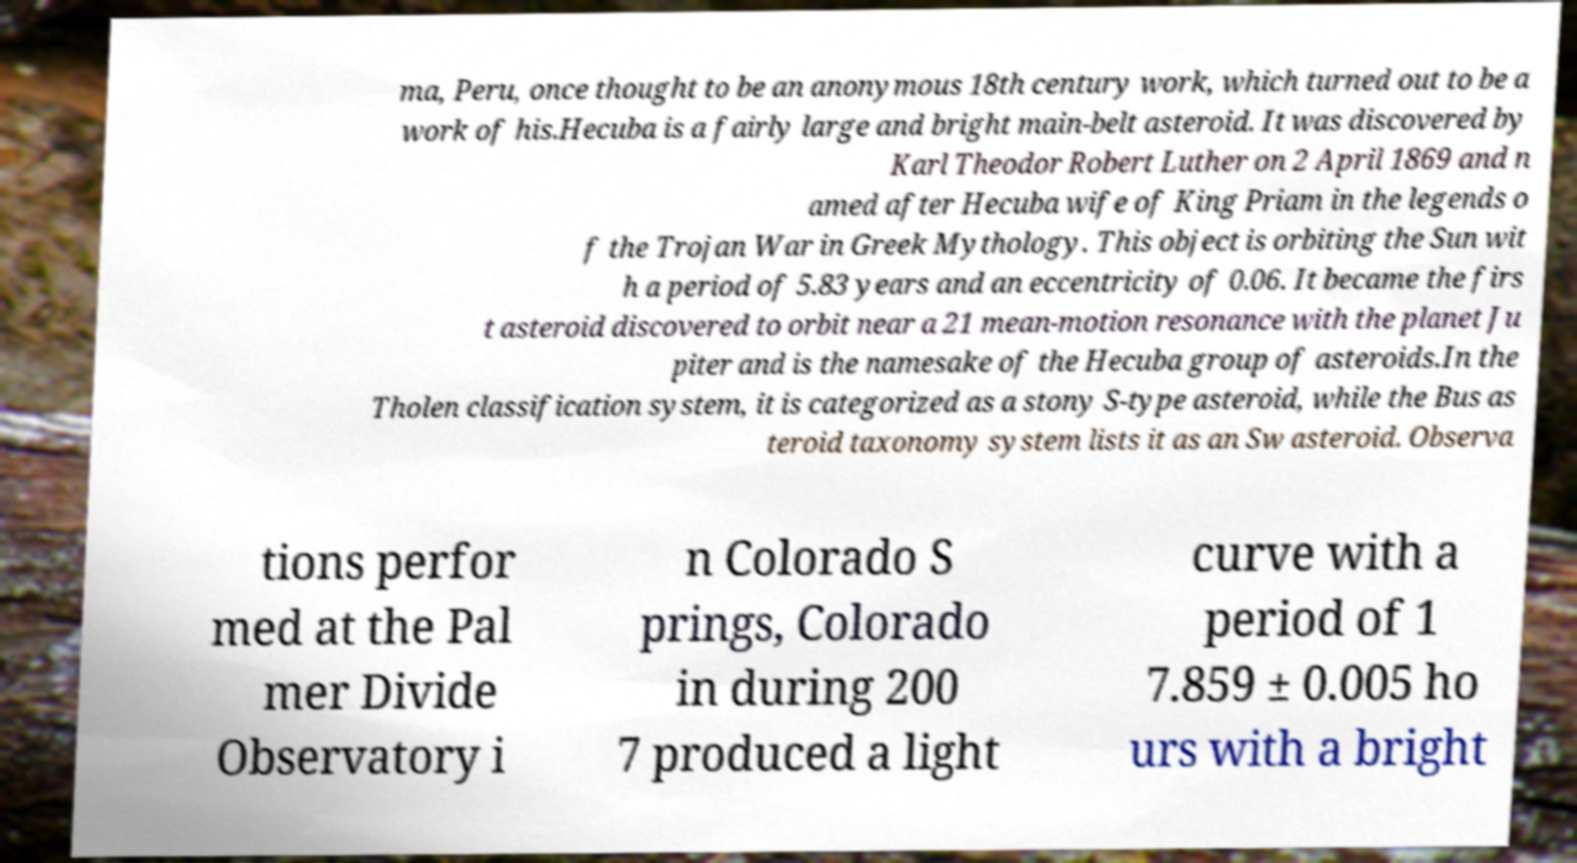Could you assist in decoding the text presented in this image and type it out clearly? ma, Peru, once thought to be an anonymous 18th century work, which turned out to be a work of his.Hecuba is a fairly large and bright main-belt asteroid. It was discovered by Karl Theodor Robert Luther on 2 April 1869 and n amed after Hecuba wife of King Priam in the legends o f the Trojan War in Greek Mythology. This object is orbiting the Sun wit h a period of 5.83 years and an eccentricity of 0.06. It became the firs t asteroid discovered to orbit near a 21 mean-motion resonance with the planet Ju piter and is the namesake of the Hecuba group of asteroids.In the Tholen classification system, it is categorized as a stony S-type asteroid, while the Bus as teroid taxonomy system lists it as an Sw asteroid. Observa tions perfor med at the Pal mer Divide Observatory i n Colorado S prings, Colorado in during 200 7 produced a light curve with a period of 1 7.859 ± 0.005 ho urs with a bright 